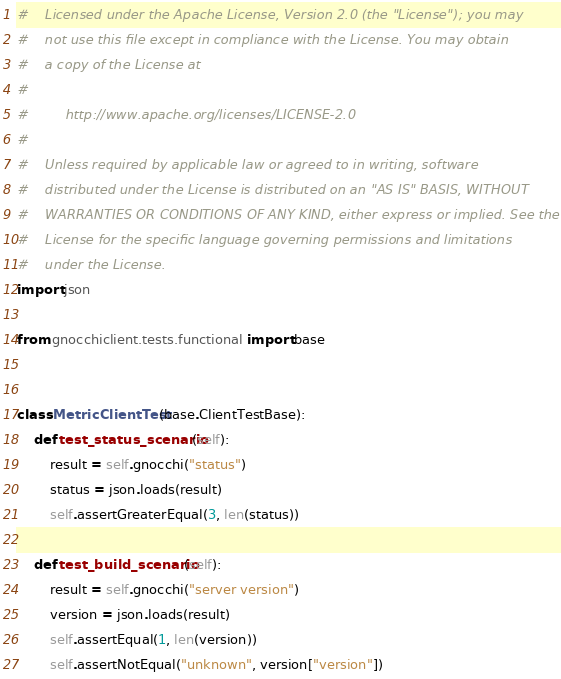<code> <loc_0><loc_0><loc_500><loc_500><_Python_>#    Licensed under the Apache License, Version 2.0 (the "License"); you may
#    not use this file except in compliance with the License. You may obtain
#    a copy of the License at
#
#         http://www.apache.org/licenses/LICENSE-2.0
#
#    Unless required by applicable law or agreed to in writing, software
#    distributed under the License is distributed on an "AS IS" BASIS, WITHOUT
#    WARRANTIES OR CONDITIONS OF ANY KIND, either express or implied. See the
#    License for the specific language governing permissions and limitations
#    under the License.
import json

from gnocchiclient.tests.functional import base


class MetricClientTest(base.ClientTestBase):
    def test_status_scenario(self):
        result = self.gnocchi("status")
        status = json.loads(result)
        self.assertGreaterEqual(3, len(status))

    def test_build_scenario(self):
        result = self.gnocchi("server version")
        version = json.loads(result)
        self.assertEqual(1, len(version))
        self.assertNotEqual("unknown", version["version"])
</code> 